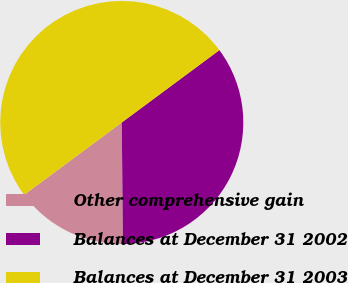Convert chart. <chart><loc_0><loc_0><loc_500><loc_500><pie_chart><fcel>Other comprehensive gain<fcel>Balances at December 31 2002<fcel>Balances at December 31 2003<nl><fcel>15.0%<fcel>35.0%<fcel>50.0%<nl></chart> 